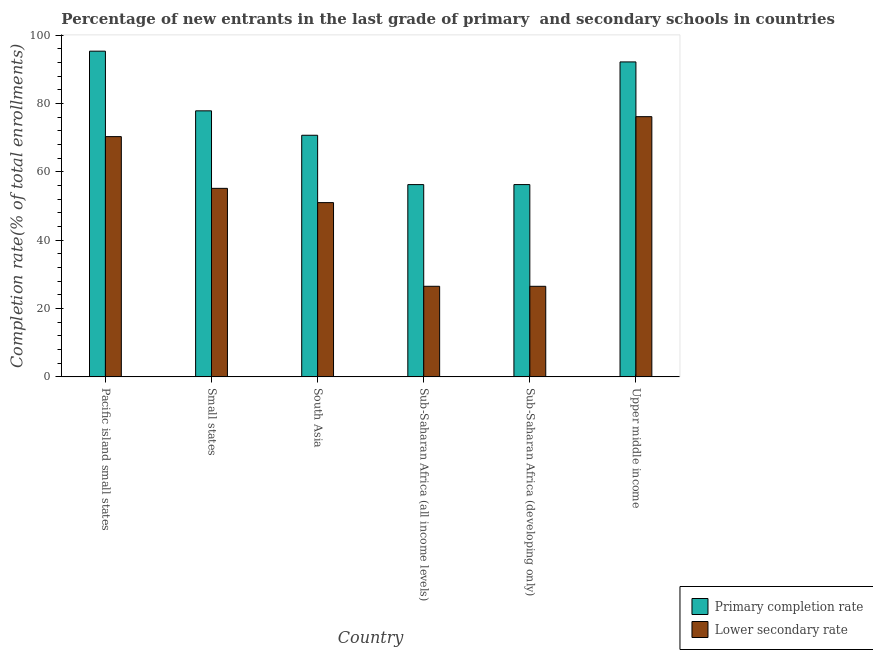How many groups of bars are there?
Your response must be concise. 6. How many bars are there on the 3rd tick from the left?
Give a very brief answer. 2. What is the label of the 2nd group of bars from the left?
Your answer should be very brief. Small states. In how many cases, is the number of bars for a given country not equal to the number of legend labels?
Make the answer very short. 0. What is the completion rate in secondary schools in Pacific island small states?
Your answer should be very brief. 70.29. Across all countries, what is the maximum completion rate in secondary schools?
Offer a very short reply. 76.13. Across all countries, what is the minimum completion rate in primary schools?
Offer a terse response. 56.25. In which country was the completion rate in primary schools maximum?
Your answer should be compact. Pacific island small states. In which country was the completion rate in secondary schools minimum?
Keep it short and to the point. Sub-Saharan Africa (developing only). What is the total completion rate in secondary schools in the graph?
Your answer should be very brief. 305.55. What is the difference between the completion rate in primary schools in Small states and that in Upper middle income?
Your response must be concise. -14.31. What is the difference between the completion rate in primary schools in Upper middle income and the completion rate in secondary schools in Sub-Saharan Africa (developing only)?
Your answer should be very brief. 65.65. What is the average completion rate in primary schools per country?
Make the answer very short. 74.74. What is the difference between the completion rate in primary schools and completion rate in secondary schools in Pacific island small states?
Ensure brevity in your answer.  25. What is the ratio of the completion rate in primary schools in Pacific island small states to that in Sub-Saharan Africa (all income levels)?
Provide a short and direct response. 1.69. What is the difference between the highest and the second highest completion rate in primary schools?
Offer a very short reply. 3.15. What is the difference between the highest and the lowest completion rate in secondary schools?
Your response must be concise. 49.63. In how many countries, is the completion rate in primary schools greater than the average completion rate in primary schools taken over all countries?
Offer a very short reply. 3. What does the 2nd bar from the left in South Asia represents?
Provide a succinct answer. Lower secondary rate. What does the 1st bar from the right in South Asia represents?
Keep it short and to the point. Lower secondary rate. How many bars are there?
Your response must be concise. 12. What is the difference between two consecutive major ticks on the Y-axis?
Keep it short and to the point. 20. Are the values on the major ticks of Y-axis written in scientific E-notation?
Make the answer very short. No. Does the graph contain any zero values?
Offer a terse response. No. Does the graph contain grids?
Your answer should be very brief. No. What is the title of the graph?
Your response must be concise. Percentage of new entrants in the last grade of primary  and secondary schools in countries. What is the label or title of the X-axis?
Give a very brief answer. Country. What is the label or title of the Y-axis?
Your answer should be compact. Completion rate(% of total enrollments). What is the Completion rate(% of total enrollments) of Primary completion rate in Pacific island small states?
Your response must be concise. 95.29. What is the Completion rate(% of total enrollments) in Lower secondary rate in Pacific island small states?
Your response must be concise. 70.29. What is the Completion rate(% of total enrollments) of Primary completion rate in Small states?
Your answer should be very brief. 77.83. What is the Completion rate(% of total enrollments) in Lower secondary rate in Small states?
Give a very brief answer. 55.16. What is the Completion rate(% of total enrollments) of Primary completion rate in South Asia?
Provide a succinct answer. 70.68. What is the Completion rate(% of total enrollments) in Lower secondary rate in South Asia?
Your response must be concise. 50.98. What is the Completion rate(% of total enrollments) in Primary completion rate in Sub-Saharan Africa (all income levels)?
Your response must be concise. 56.25. What is the Completion rate(% of total enrollments) of Lower secondary rate in Sub-Saharan Africa (all income levels)?
Give a very brief answer. 26.5. What is the Completion rate(% of total enrollments) of Primary completion rate in Sub-Saharan Africa (developing only)?
Provide a short and direct response. 56.25. What is the Completion rate(% of total enrollments) in Lower secondary rate in Sub-Saharan Africa (developing only)?
Your response must be concise. 26.5. What is the Completion rate(% of total enrollments) in Primary completion rate in Upper middle income?
Offer a terse response. 92.14. What is the Completion rate(% of total enrollments) of Lower secondary rate in Upper middle income?
Give a very brief answer. 76.13. Across all countries, what is the maximum Completion rate(% of total enrollments) of Primary completion rate?
Ensure brevity in your answer.  95.29. Across all countries, what is the maximum Completion rate(% of total enrollments) in Lower secondary rate?
Make the answer very short. 76.13. Across all countries, what is the minimum Completion rate(% of total enrollments) of Primary completion rate?
Keep it short and to the point. 56.25. Across all countries, what is the minimum Completion rate(% of total enrollments) of Lower secondary rate?
Give a very brief answer. 26.5. What is the total Completion rate(% of total enrollments) in Primary completion rate in the graph?
Offer a terse response. 448.45. What is the total Completion rate(% of total enrollments) in Lower secondary rate in the graph?
Your response must be concise. 305.55. What is the difference between the Completion rate(% of total enrollments) in Primary completion rate in Pacific island small states and that in Small states?
Your answer should be very brief. 17.46. What is the difference between the Completion rate(% of total enrollments) of Lower secondary rate in Pacific island small states and that in Small states?
Make the answer very short. 15.13. What is the difference between the Completion rate(% of total enrollments) in Primary completion rate in Pacific island small states and that in South Asia?
Offer a very short reply. 24.61. What is the difference between the Completion rate(% of total enrollments) of Lower secondary rate in Pacific island small states and that in South Asia?
Keep it short and to the point. 19.31. What is the difference between the Completion rate(% of total enrollments) of Primary completion rate in Pacific island small states and that in Sub-Saharan Africa (all income levels)?
Give a very brief answer. 39.04. What is the difference between the Completion rate(% of total enrollments) of Lower secondary rate in Pacific island small states and that in Sub-Saharan Africa (all income levels)?
Give a very brief answer. 43.79. What is the difference between the Completion rate(% of total enrollments) in Primary completion rate in Pacific island small states and that in Sub-Saharan Africa (developing only)?
Your answer should be very brief. 39.04. What is the difference between the Completion rate(% of total enrollments) in Lower secondary rate in Pacific island small states and that in Sub-Saharan Africa (developing only)?
Make the answer very short. 43.79. What is the difference between the Completion rate(% of total enrollments) in Primary completion rate in Pacific island small states and that in Upper middle income?
Provide a short and direct response. 3.15. What is the difference between the Completion rate(% of total enrollments) of Lower secondary rate in Pacific island small states and that in Upper middle income?
Ensure brevity in your answer.  -5.84. What is the difference between the Completion rate(% of total enrollments) in Primary completion rate in Small states and that in South Asia?
Your response must be concise. 7.15. What is the difference between the Completion rate(% of total enrollments) of Lower secondary rate in Small states and that in South Asia?
Make the answer very short. 4.18. What is the difference between the Completion rate(% of total enrollments) in Primary completion rate in Small states and that in Sub-Saharan Africa (all income levels)?
Ensure brevity in your answer.  21.58. What is the difference between the Completion rate(% of total enrollments) in Lower secondary rate in Small states and that in Sub-Saharan Africa (all income levels)?
Provide a short and direct response. 28.66. What is the difference between the Completion rate(% of total enrollments) in Primary completion rate in Small states and that in Sub-Saharan Africa (developing only)?
Offer a terse response. 21.58. What is the difference between the Completion rate(% of total enrollments) in Lower secondary rate in Small states and that in Sub-Saharan Africa (developing only)?
Your response must be concise. 28.66. What is the difference between the Completion rate(% of total enrollments) in Primary completion rate in Small states and that in Upper middle income?
Provide a short and direct response. -14.31. What is the difference between the Completion rate(% of total enrollments) of Lower secondary rate in Small states and that in Upper middle income?
Your answer should be compact. -20.97. What is the difference between the Completion rate(% of total enrollments) of Primary completion rate in South Asia and that in Sub-Saharan Africa (all income levels)?
Provide a succinct answer. 14.44. What is the difference between the Completion rate(% of total enrollments) of Lower secondary rate in South Asia and that in Sub-Saharan Africa (all income levels)?
Keep it short and to the point. 24.48. What is the difference between the Completion rate(% of total enrollments) in Primary completion rate in South Asia and that in Sub-Saharan Africa (developing only)?
Your answer should be compact. 14.43. What is the difference between the Completion rate(% of total enrollments) of Lower secondary rate in South Asia and that in Sub-Saharan Africa (developing only)?
Make the answer very short. 24.48. What is the difference between the Completion rate(% of total enrollments) of Primary completion rate in South Asia and that in Upper middle income?
Make the answer very short. -21.46. What is the difference between the Completion rate(% of total enrollments) in Lower secondary rate in South Asia and that in Upper middle income?
Give a very brief answer. -25.15. What is the difference between the Completion rate(% of total enrollments) in Primary completion rate in Sub-Saharan Africa (all income levels) and that in Sub-Saharan Africa (developing only)?
Provide a short and direct response. -0. What is the difference between the Completion rate(% of total enrollments) of Lower secondary rate in Sub-Saharan Africa (all income levels) and that in Sub-Saharan Africa (developing only)?
Your answer should be compact. 0. What is the difference between the Completion rate(% of total enrollments) of Primary completion rate in Sub-Saharan Africa (all income levels) and that in Upper middle income?
Provide a short and direct response. -35.89. What is the difference between the Completion rate(% of total enrollments) in Lower secondary rate in Sub-Saharan Africa (all income levels) and that in Upper middle income?
Your answer should be very brief. -49.63. What is the difference between the Completion rate(% of total enrollments) of Primary completion rate in Sub-Saharan Africa (developing only) and that in Upper middle income?
Offer a terse response. -35.89. What is the difference between the Completion rate(% of total enrollments) in Lower secondary rate in Sub-Saharan Africa (developing only) and that in Upper middle income?
Ensure brevity in your answer.  -49.63. What is the difference between the Completion rate(% of total enrollments) in Primary completion rate in Pacific island small states and the Completion rate(% of total enrollments) in Lower secondary rate in Small states?
Make the answer very short. 40.13. What is the difference between the Completion rate(% of total enrollments) in Primary completion rate in Pacific island small states and the Completion rate(% of total enrollments) in Lower secondary rate in South Asia?
Your answer should be compact. 44.31. What is the difference between the Completion rate(% of total enrollments) in Primary completion rate in Pacific island small states and the Completion rate(% of total enrollments) in Lower secondary rate in Sub-Saharan Africa (all income levels)?
Offer a terse response. 68.79. What is the difference between the Completion rate(% of total enrollments) in Primary completion rate in Pacific island small states and the Completion rate(% of total enrollments) in Lower secondary rate in Sub-Saharan Africa (developing only)?
Your answer should be compact. 68.79. What is the difference between the Completion rate(% of total enrollments) of Primary completion rate in Pacific island small states and the Completion rate(% of total enrollments) of Lower secondary rate in Upper middle income?
Offer a very short reply. 19.16. What is the difference between the Completion rate(% of total enrollments) of Primary completion rate in Small states and the Completion rate(% of total enrollments) of Lower secondary rate in South Asia?
Offer a very short reply. 26.85. What is the difference between the Completion rate(% of total enrollments) of Primary completion rate in Small states and the Completion rate(% of total enrollments) of Lower secondary rate in Sub-Saharan Africa (all income levels)?
Your answer should be compact. 51.33. What is the difference between the Completion rate(% of total enrollments) in Primary completion rate in Small states and the Completion rate(% of total enrollments) in Lower secondary rate in Sub-Saharan Africa (developing only)?
Your answer should be compact. 51.34. What is the difference between the Completion rate(% of total enrollments) of Primary completion rate in Small states and the Completion rate(% of total enrollments) of Lower secondary rate in Upper middle income?
Your answer should be compact. 1.71. What is the difference between the Completion rate(% of total enrollments) in Primary completion rate in South Asia and the Completion rate(% of total enrollments) in Lower secondary rate in Sub-Saharan Africa (all income levels)?
Keep it short and to the point. 44.19. What is the difference between the Completion rate(% of total enrollments) in Primary completion rate in South Asia and the Completion rate(% of total enrollments) in Lower secondary rate in Sub-Saharan Africa (developing only)?
Offer a terse response. 44.19. What is the difference between the Completion rate(% of total enrollments) in Primary completion rate in South Asia and the Completion rate(% of total enrollments) in Lower secondary rate in Upper middle income?
Offer a very short reply. -5.44. What is the difference between the Completion rate(% of total enrollments) of Primary completion rate in Sub-Saharan Africa (all income levels) and the Completion rate(% of total enrollments) of Lower secondary rate in Sub-Saharan Africa (developing only)?
Provide a short and direct response. 29.75. What is the difference between the Completion rate(% of total enrollments) of Primary completion rate in Sub-Saharan Africa (all income levels) and the Completion rate(% of total enrollments) of Lower secondary rate in Upper middle income?
Give a very brief answer. -19.88. What is the difference between the Completion rate(% of total enrollments) of Primary completion rate in Sub-Saharan Africa (developing only) and the Completion rate(% of total enrollments) of Lower secondary rate in Upper middle income?
Your answer should be very brief. -19.87. What is the average Completion rate(% of total enrollments) in Primary completion rate per country?
Offer a terse response. 74.74. What is the average Completion rate(% of total enrollments) of Lower secondary rate per country?
Your answer should be very brief. 50.92. What is the difference between the Completion rate(% of total enrollments) of Primary completion rate and Completion rate(% of total enrollments) of Lower secondary rate in Pacific island small states?
Your answer should be very brief. 25. What is the difference between the Completion rate(% of total enrollments) in Primary completion rate and Completion rate(% of total enrollments) in Lower secondary rate in Small states?
Keep it short and to the point. 22.68. What is the difference between the Completion rate(% of total enrollments) of Primary completion rate and Completion rate(% of total enrollments) of Lower secondary rate in South Asia?
Keep it short and to the point. 19.71. What is the difference between the Completion rate(% of total enrollments) in Primary completion rate and Completion rate(% of total enrollments) in Lower secondary rate in Sub-Saharan Africa (all income levels)?
Offer a terse response. 29.75. What is the difference between the Completion rate(% of total enrollments) in Primary completion rate and Completion rate(% of total enrollments) in Lower secondary rate in Sub-Saharan Africa (developing only)?
Provide a succinct answer. 29.76. What is the difference between the Completion rate(% of total enrollments) in Primary completion rate and Completion rate(% of total enrollments) in Lower secondary rate in Upper middle income?
Your answer should be compact. 16.02. What is the ratio of the Completion rate(% of total enrollments) in Primary completion rate in Pacific island small states to that in Small states?
Ensure brevity in your answer.  1.22. What is the ratio of the Completion rate(% of total enrollments) of Lower secondary rate in Pacific island small states to that in Small states?
Your answer should be very brief. 1.27. What is the ratio of the Completion rate(% of total enrollments) of Primary completion rate in Pacific island small states to that in South Asia?
Give a very brief answer. 1.35. What is the ratio of the Completion rate(% of total enrollments) of Lower secondary rate in Pacific island small states to that in South Asia?
Your answer should be compact. 1.38. What is the ratio of the Completion rate(% of total enrollments) in Primary completion rate in Pacific island small states to that in Sub-Saharan Africa (all income levels)?
Provide a succinct answer. 1.69. What is the ratio of the Completion rate(% of total enrollments) of Lower secondary rate in Pacific island small states to that in Sub-Saharan Africa (all income levels)?
Your answer should be very brief. 2.65. What is the ratio of the Completion rate(% of total enrollments) in Primary completion rate in Pacific island small states to that in Sub-Saharan Africa (developing only)?
Your answer should be very brief. 1.69. What is the ratio of the Completion rate(% of total enrollments) in Lower secondary rate in Pacific island small states to that in Sub-Saharan Africa (developing only)?
Provide a succinct answer. 2.65. What is the ratio of the Completion rate(% of total enrollments) in Primary completion rate in Pacific island small states to that in Upper middle income?
Offer a very short reply. 1.03. What is the ratio of the Completion rate(% of total enrollments) of Lower secondary rate in Pacific island small states to that in Upper middle income?
Your response must be concise. 0.92. What is the ratio of the Completion rate(% of total enrollments) in Primary completion rate in Small states to that in South Asia?
Your response must be concise. 1.1. What is the ratio of the Completion rate(% of total enrollments) in Lower secondary rate in Small states to that in South Asia?
Keep it short and to the point. 1.08. What is the ratio of the Completion rate(% of total enrollments) in Primary completion rate in Small states to that in Sub-Saharan Africa (all income levels)?
Ensure brevity in your answer.  1.38. What is the ratio of the Completion rate(% of total enrollments) in Lower secondary rate in Small states to that in Sub-Saharan Africa (all income levels)?
Ensure brevity in your answer.  2.08. What is the ratio of the Completion rate(% of total enrollments) in Primary completion rate in Small states to that in Sub-Saharan Africa (developing only)?
Your answer should be very brief. 1.38. What is the ratio of the Completion rate(% of total enrollments) of Lower secondary rate in Small states to that in Sub-Saharan Africa (developing only)?
Your answer should be compact. 2.08. What is the ratio of the Completion rate(% of total enrollments) in Primary completion rate in Small states to that in Upper middle income?
Your answer should be compact. 0.84. What is the ratio of the Completion rate(% of total enrollments) of Lower secondary rate in Small states to that in Upper middle income?
Ensure brevity in your answer.  0.72. What is the ratio of the Completion rate(% of total enrollments) in Primary completion rate in South Asia to that in Sub-Saharan Africa (all income levels)?
Give a very brief answer. 1.26. What is the ratio of the Completion rate(% of total enrollments) of Lower secondary rate in South Asia to that in Sub-Saharan Africa (all income levels)?
Keep it short and to the point. 1.92. What is the ratio of the Completion rate(% of total enrollments) of Primary completion rate in South Asia to that in Sub-Saharan Africa (developing only)?
Offer a terse response. 1.26. What is the ratio of the Completion rate(% of total enrollments) in Lower secondary rate in South Asia to that in Sub-Saharan Africa (developing only)?
Ensure brevity in your answer.  1.92. What is the ratio of the Completion rate(% of total enrollments) of Primary completion rate in South Asia to that in Upper middle income?
Provide a short and direct response. 0.77. What is the ratio of the Completion rate(% of total enrollments) of Lower secondary rate in South Asia to that in Upper middle income?
Keep it short and to the point. 0.67. What is the ratio of the Completion rate(% of total enrollments) in Primary completion rate in Sub-Saharan Africa (all income levels) to that in Sub-Saharan Africa (developing only)?
Your answer should be very brief. 1. What is the ratio of the Completion rate(% of total enrollments) in Lower secondary rate in Sub-Saharan Africa (all income levels) to that in Sub-Saharan Africa (developing only)?
Your response must be concise. 1. What is the ratio of the Completion rate(% of total enrollments) of Primary completion rate in Sub-Saharan Africa (all income levels) to that in Upper middle income?
Your answer should be very brief. 0.61. What is the ratio of the Completion rate(% of total enrollments) in Lower secondary rate in Sub-Saharan Africa (all income levels) to that in Upper middle income?
Your response must be concise. 0.35. What is the ratio of the Completion rate(% of total enrollments) in Primary completion rate in Sub-Saharan Africa (developing only) to that in Upper middle income?
Make the answer very short. 0.61. What is the ratio of the Completion rate(% of total enrollments) of Lower secondary rate in Sub-Saharan Africa (developing only) to that in Upper middle income?
Make the answer very short. 0.35. What is the difference between the highest and the second highest Completion rate(% of total enrollments) in Primary completion rate?
Offer a terse response. 3.15. What is the difference between the highest and the second highest Completion rate(% of total enrollments) of Lower secondary rate?
Provide a succinct answer. 5.84. What is the difference between the highest and the lowest Completion rate(% of total enrollments) in Primary completion rate?
Keep it short and to the point. 39.04. What is the difference between the highest and the lowest Completion rate(% of total enrollments) of Lower secondary rate?
Give a very brief answer. 49.63. 